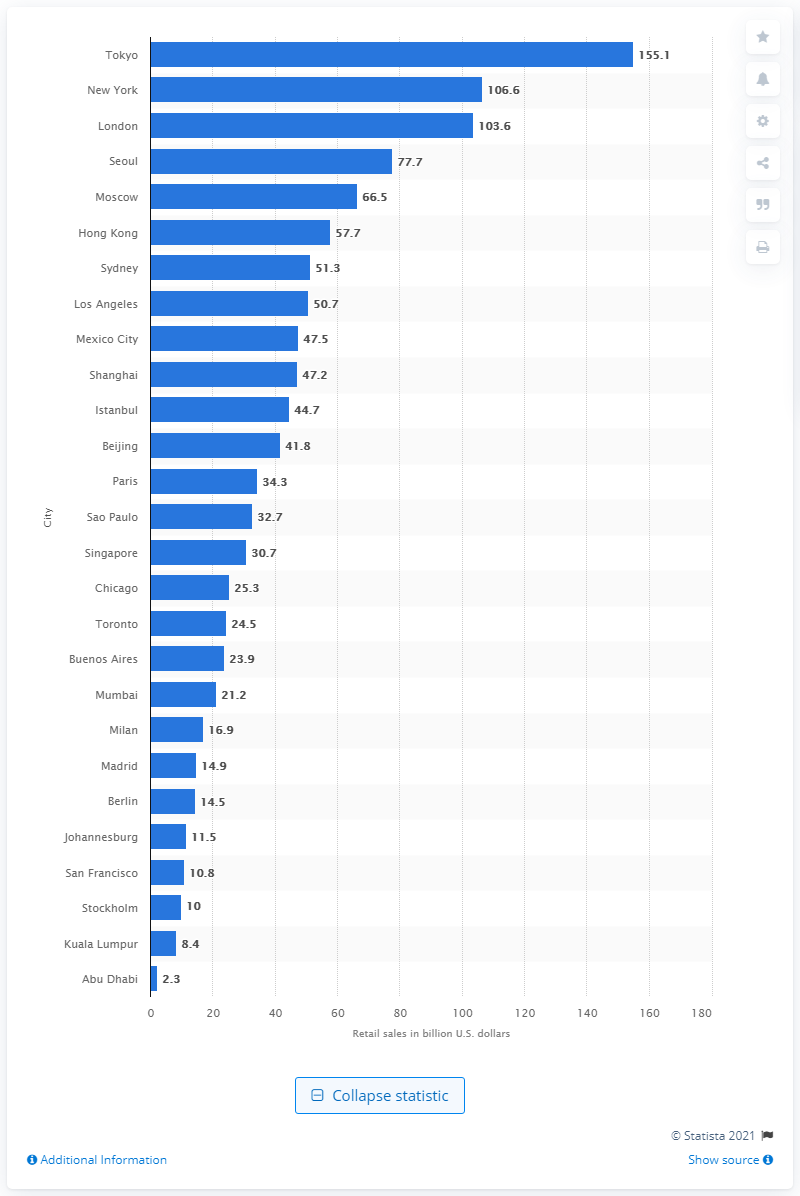Draw attention to some important aspects in this diagram. In 2012, Tokyo's retail sales were 155.1 billion yen. In 2012, Tokyo was the leading city in the world. 